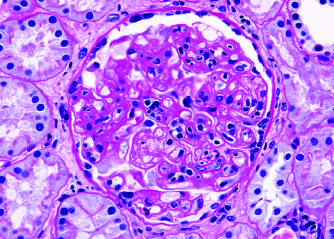does the extensive subcutaneous fibrosis show inflammatory cells within the capillary loops glomerulitis, accumulation of mesangial matrix, and duplication of the capillary basement membrane?
Answer the question using a single word or phrase. No 